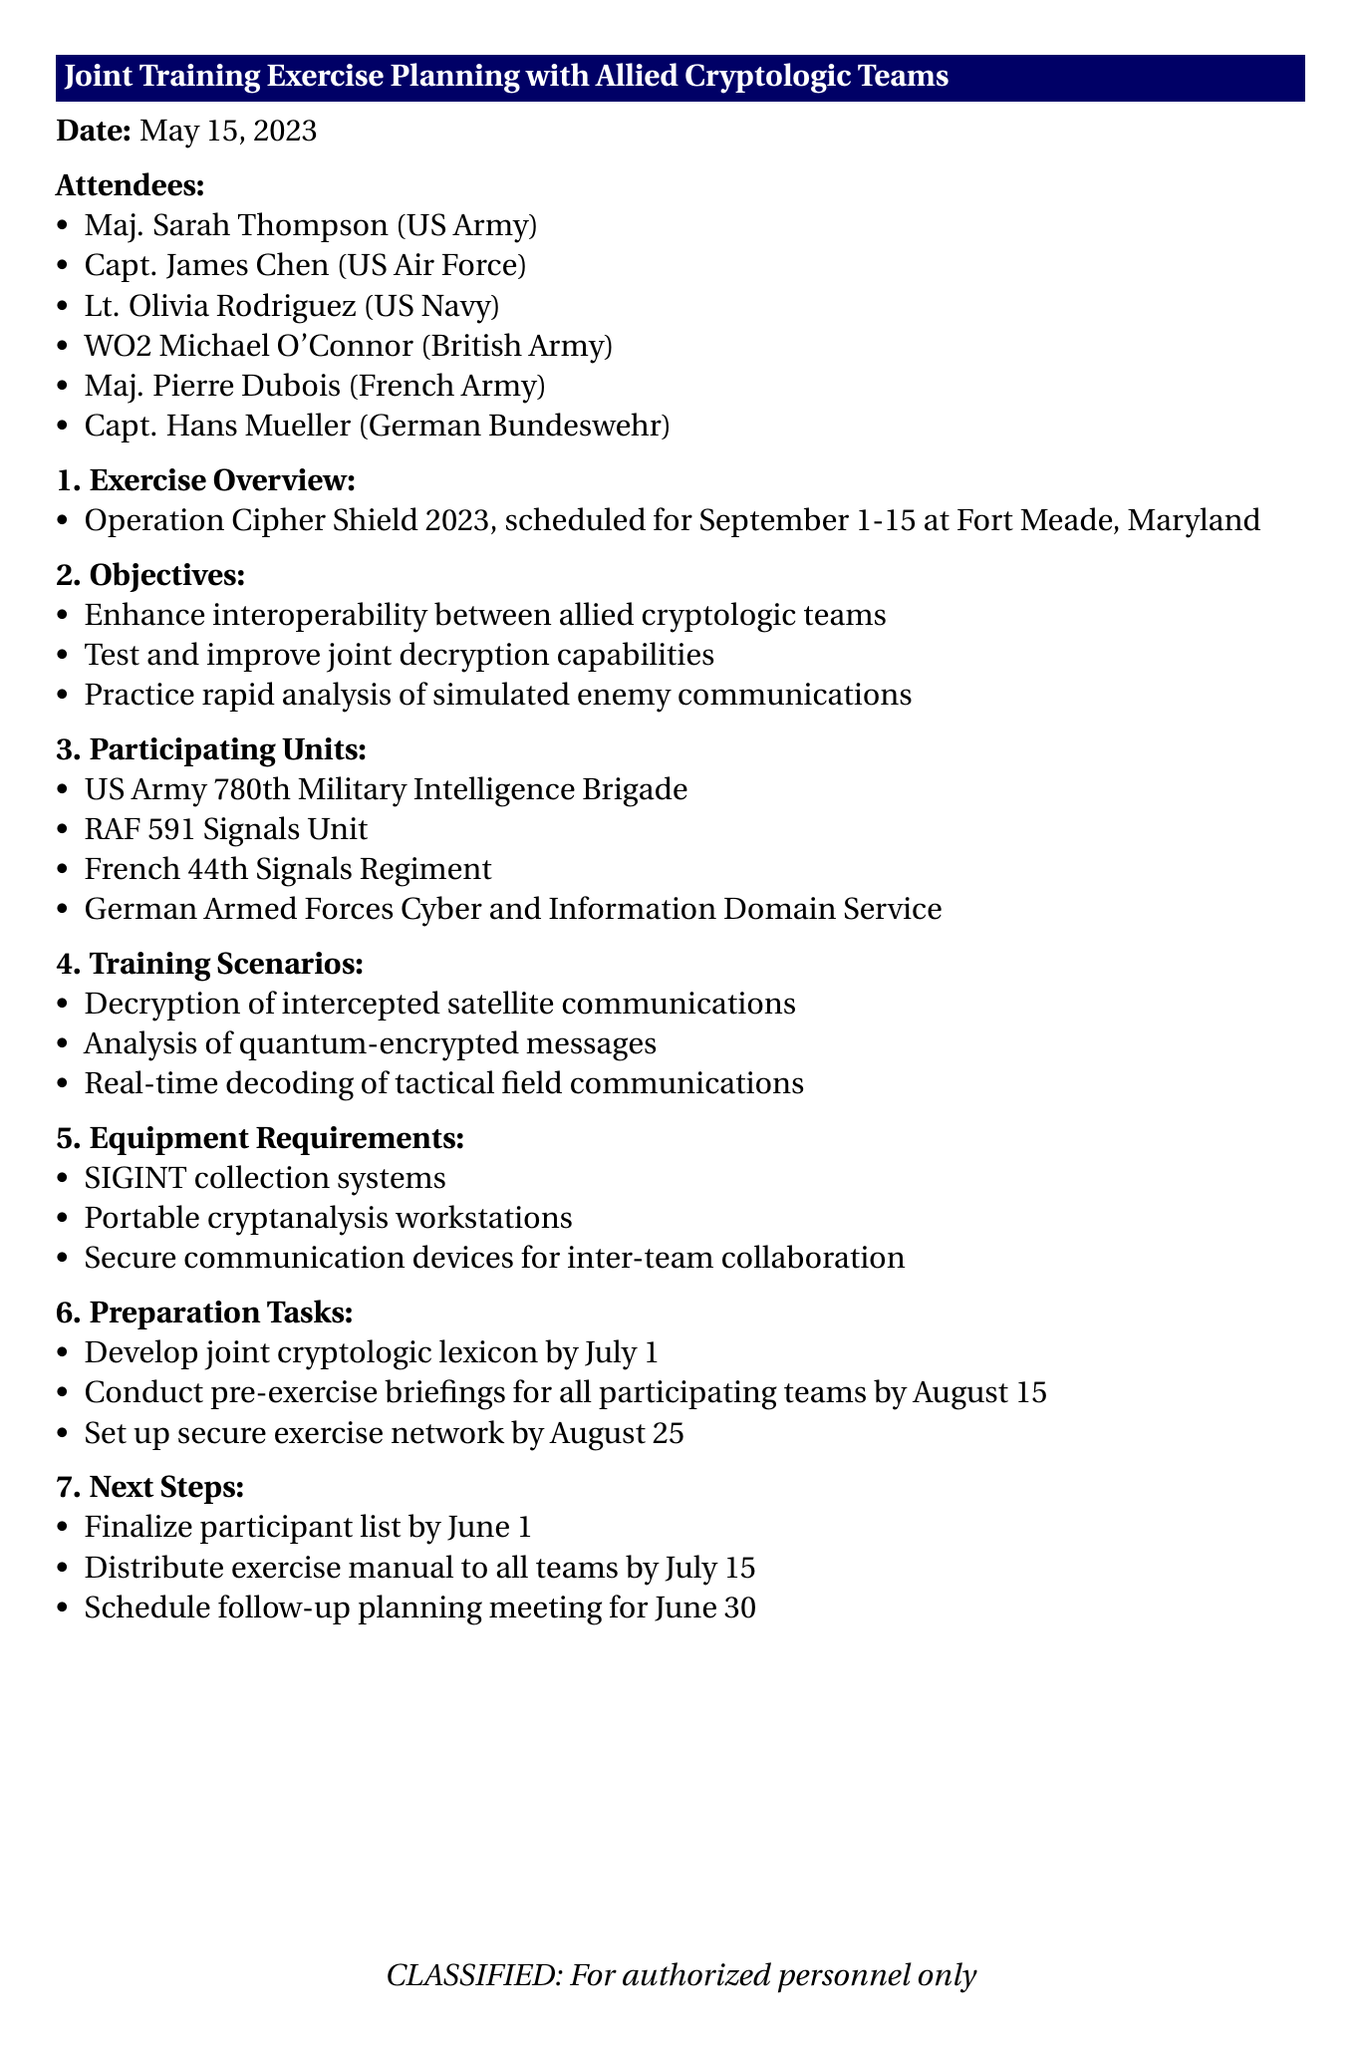What is the title of the meeting? The title of the meeting is explicitly stated at the beginning of the document, which is "Joint Training Exercise Planning with Allied Cryptologic Teams."
Answer: Joint Training Exercise Planning with Allied Cryptologic Teams When is Operation Cipher Shield 2023 scheduled? The document specifies the dates for Operation Cipher Shield 2023 as September 1-15.
Answer: September 1-15 Who is the attendee from the British Army? The document lists the specific attendees by name and branch, indicating WO2 Michael O'Connor represents the British Army.
Answer: WO2 Michael O'Connor What are the three listed objectives of the exercise? The document outlines three main objectives for the exercise, which can be directly extracted from the "Objectives" section.
Answer: Enhance interoperability between allied cryptologic teams, Test and improve joint decryption capabilities, Practice rapid analysis of simulated enemy communications What is one of the preparation tasks to be completed by July 1? The document includes a specific task in the "Preparation Tasks" section that mentions developing a joint cryptologic lexicon by July 1.
Answer: Develop joint cryptologic lexicon What is the follow-up planning meeting date? The document indicates that the next planning meeting is scheduled for June 30, as highlighted in the "Next Steps" section.
Answer: June 30 What unit is participating from the German Bundeswehr? The document specifies the German Armed Forces Cyber and Information Domain Service as the participating unit from Germany.
Answer: German Armed Forces Cyber and Information Domain Service How many training scenarios are listed in the document? The document outlines three training scenarios, which can be counted directly from the "Training Scenarios" section.
Answer: Three 